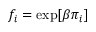Convert formula to latex. <formula><loc_0><loc_0><loc_500><loc_500>f _ { i } = \exp [ \beta \pi _ { i } ]</formula> 